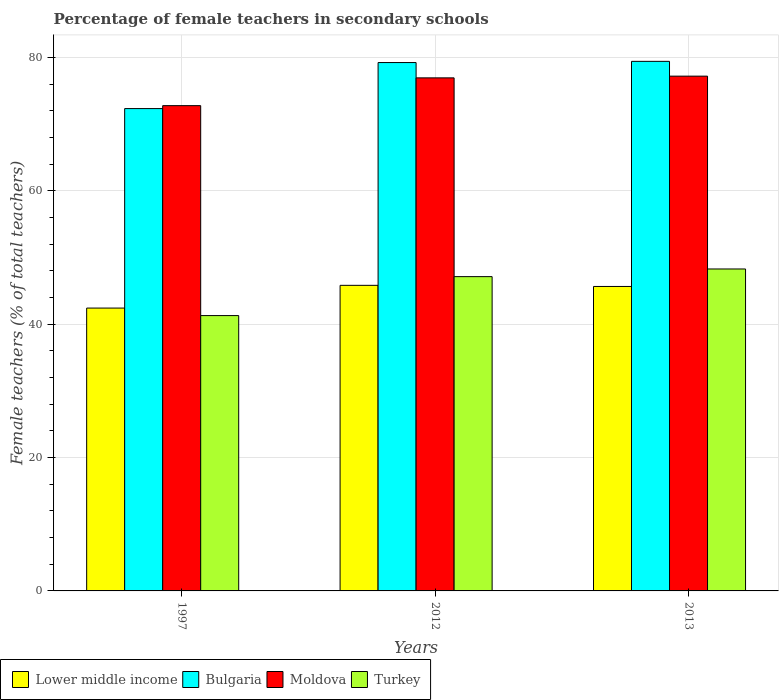How many groups of bars are there?
Offer a terse response. 3. Are the number of bars on each tick of the X-axis equal?
Your response must be concise. Yes. How many bars are there on the 1st tick from the left?
Ensure brevity in your answer.  4. In how many cases, is the number of bars for a given year not equal to the number of legend labels?
Make the answer very short. 0. What is the percentage of female teachers in Moldova in 1997?
Your response must be concise. 72.8. Across all years, what is the maximum percentage of female teachers in Lower middle income?
Ensure brevity in your answer.  45.84. Across all years, what is the minimum percentage of female teachers in Bulgaria?
Offer a very short reply. 72.36. In which year was the percentage of female teachers in Lower middle income maximum?
Provide a short and direct response. 2012. In which year was the percentage of female teachers in Bulgaria minimum?
Give a very brief answer. 1997. What is the total percentage of female teachers in Turkey in the graph?
Your answer should be very brief. 136.75. What is the difference between the percentage of female teachers in Moldova in 2012 and that in 2013?
Offer a very short reply. -0.26. What is the difference between the percentage of female teachers in Bulgaria in 1997 and the percentage of female teachers in Turkey in 2013?
Your response must be concise. 24.06. What is the average percentage of female teachers in Lower middle income per year?
Your answer should be compact. 44.65. In the year 2012, what is the difference between the percentage of female teachers in Turkey and percentage of female teachers in Bulgaria?
Keep it short and to the point. -32.12. In how many years, is the percentage of female teachers in Moldova greater than 40 %?
Make the answer very short. 3. What is the ratio of the percentage of female teachers in Lower middle income in 1997 to that in 2012?
Keep it short and to the point. 0.93. Is the percentage of female teachers in Turkey in 1997 less than that in 2013?
Ensure brevity in your answer.  Yes. Is the difference between the percentage of female teachers in Turkey in 1997 and 2013 greater than the difference between the percentage of female teachers in Bulgaria in 1997 and 2013?
Offer a terse response. Yes. What is the difference between the highest and the second highest percentage of female teachers in Bulgaria?
Your answer should be compact. 0.18. What is the difference between the highest and the lowest percentage of female teachers in Lower middle income?
Your answer should be very brief. 3.41. In how many years, is the percentage of female teachers in Bulgaria greater than the average percentage of female teachers in Bulgaria taken over all years?
Offer a very short reply. 2. Is it the case that in every year, the sum of the percentage of female teachers in Lower middle income and percentage of female teachers in Bulgaria is greater than the sum of percentage of female teachers in Moldova and percentage of female teachers in Turkey?
Make the answer very short. No. What does the 3rd bar from the right in 1997 represents?
Ensure brevity in your answer.  Bulgaria. How many bars are there?
Offer a very short reply. 12. How many years are there in the graph?
Keep it short and to the point. 3. Are the values on the major ticks of Y-axis written in scientific E-notation?
Give a very brief answer. No. Does the graph contain grids?
Your answer should be compact. Yes. How are the legend labels stacked?
Offer a terse response. Horizontal. What is the title of the graph?
Your response must be concise. Percentage of female teachers in secondary schools. What is the label or title of the Y-axis?
Your answer should be very brief. Female teachers (% of total teachers). What is the Female teachers (% of total teachers) in Lower middle income in 1997?
Provide a short and direct response. 42.43. What is the Female teachers (% of total teachers) in Bulgaria in 1997?
Give a very brief answer. 72.36. What is the Female teachers (% of total teachers) of Moldova in 1997?
Offer a very short reply. 72.8. What is the Female teachers (% of total teachers) in Turkey in 1997?
Offer a very short reply. 41.31. What is the Female teachers (% of total teachers) in Lower middle income in 2012?
Provide a short and direct response. 45.84. What is the Female teachers (% of total teachers) of Bulgaria in 2012?
Provide a short and direct response. 79.27. What is the Female teachers (% of total teachers) in Moldova in 2012?
Give a very brief answer. 76.97. What is the Female teachers (% of total teachers) of Turkey in 2012?
Offer a very short reply. 47.15. What is the Female teachers (% of total teachers) of Lower middle income in 2013?
Give a very brief answer. 45.68. What is the Female teachers (% of total teachers) of Bulgaria in 2013?
Offer a terse response. 79.45. What is the Female teachers (% of total teachers) of Moldova in 2013?
Your answer should be very brief. 77.23. What is the Female teachers (% of total teachers) in Turkey in 2013?
Provide a short and direct response. 48.3. Across all years, what is the maximum Female teachers (% of total teachers) in Lower middle income?
Keep it short and to the point. 45.84. Across all years, what is the maximum Female teachers (% of total teachers) in Bulgaria?
Provide a short and direct response. 79.45. Across all years, what is the maximum Female teachers (% of total teachers) of Moldova?
Your answer should be very brief. 77.23. Across all years, what is the maximum Female teachers (% of total teachers) of Turkey?
Provide a short and direct response. 48.3. Across all years, what is the minimum Female teachers (% of total teachers) in Lower middle income?
Ensure brevity in your answer.  42.43. Across all years, what is the minimum Female teachers (% of total teachers) in Bulgaria?
Offer a terse response. 72.36. Across all years, what is the minimum Female teachers (% of total teachers) in Moldova?
Provide a short and direct response. 72.8. Across all years, what is the minimum Female teachers (% of total teachers) of Turkey?
Offer a very short reply. 41.31. What is the total Female teachers (% of total teachers) in Lower middle income in the graph?
Your answer should be very brief. 133.95. What is the total Female teachers (% of total teachers) in Bulgaria in the graph?
Provide a short and direct response. 231.07. What is the total Female teachers (% of total teachers) of Moldova in the graph?
Offer a very short reply. 227. What is the total Female teachers (% of total teachers) in Turkey in the graph?
Your answer should be compact. 136.75. What is the difference between the Female teachers (% of total teachers) in Lower middle income in 1997 and that in 2012?
Offer a very short reply. -3.41. What is the difference between the Female teachers (% of total teachers) in Bulgaria in 1997 and that in 2012?
Your response must be concise. -6.91. What is the difference between the Female teachers (% of total teachers) of Moldova in 1997 and that in 2012?
Your response must be concise. -4.17. What is the difference between the Female teachers (% of total teachers) of Turkey in 1997 and that in 2012?
Give a very brief answer. -5.85. What is the difference between the Female teachers (% of total teachers) in Lower middle income in 1997 and that in 2013?
Give a very brief answer. -3.24. What is the difference between the Female teachers (% of total teachers) of Bulgaria in 1997 and that in 2013?
Ensure brevity in your answer.  -7.09. What is the difference between the Female teachers (% of total teachers) in Moldova in 1997 and that in 2013?
Ensure brevity in your answer.  -4.43. What is the difference between the Female teachers (% of total teachers) of Turkey in 1997 and that in 2013?
Your answer should be very brief. -6.99. What is the difference between the Female teachers (% of total teachers) of Lower middle income in 2012 and that in 2013?
Your answer should be compact. 0.17. What is the difference between the Female teachers (% of total teachers) in Bulgaria in 2012 and that in 2013?
Keep it short and to the point. -0.18. What is the difference between the Female teachers (% of total teachers) of Moldova in 2012 and that in 2013?
Provide a short and direct response. -0.26. What is the difference between the Female teachers (% of total teachers) of Turkey in 2012 and that in 2013?
Keep it short and to the point. -1.15. What is the difference between the Female teachers (% of total teachers) of Lower middle income in 1997 and the Female teachers (% of total teachers) of Bulgaria in 2012?
Your answer should be compact. -36.83. What is the difference between the Female teachers (% of total teachers) of Lower middle income in 1997 and the Female teachers (% of total teachers) of Moldova in 2012?
Offer a very short reply. -34.54. What is the difference between the Female teachers (% of total teachers) of Lower middle income in 1997 and the Female teachers (% of total teachers) of Turkey in 2012?
Provide a short and direct response. -4.72. What is the difference between the Female teachers (% of total teachers) of Bulgaria in 1997 and the Female teachers (% of total teachers) of Moldova in 2012?
Give a very brief answer. -4.61. What is the difference between the Female teachers (% of total teachers) in Bulgaria in 1997 and the Female teachers (% of total teachers) in Turkey in 2012?
Ensure brevity in your answer.  25.21. What is the difference between the Female teachers (% of total teachers) of Moldova in 1997 and the Female teachers (% of total teachers) of Turkey in 2012?
Provide a succinct answer. 25.65. What is the difference between the Female teachers (% of total teachers) in Lower middle income in 1997 and the Female teachers (% of total teachers) in Bulgaria in 2013?
Ensure brevity in your answer.  -37.01. What is the difference between the Female teachers (% of total teachers) of Lower middle income in 1997 and the Female teachers (% of total teachers) of Moldova in 2013?
Make the answer very short. -34.79. What is the difference between the Female teachers (% of total teachers) in Lower middle income in 1997 and the Female teachers (% of total teachers) in Turkey in 2013?
Keep it short and to the point. -5.86. What is the difference between the Female teachers (% of total teachers) of Bulgaria in 1997 and the Female teachers (% of total teachers) of Moldova in 2013?
Keep it short and to the point. -4.87. What is the difference between the Female teachers (% of total teachers) in Bulgaria in 1997 and the Female teachers (% of total teachers) in Turkey in 2013?
Keep it short and to the point. 24.06. What is the difference between the Female teachers (% of total teachers) in Moldova in 1997 and the Female teachers (% of total teachers) in Turkey in 2013?
Make the answer very short. 24.5. What is the difference between the Female teachers (% of total teachers) in Lower middle income in 2012 and the Female teachers (% of total teachers) in Bulgaria in 2013?
Your response must be concise. -33.6. What is the difference between the Female teachers (% of total teachers) of Lower middle income in 2012 and the Female teachers (% of total teachers) of Moldova in 2013?
Keep it short and to the point. -31.38. What is the difference between the Female teachers (% of total teachers) of Lower middle income in 2012 and the Female teachers (% of total teachers) of Turkey in 2013?
Your response must be concise. -2.45. What is the difference between the Female teachers (% of total teachers) in Bulgaria in 2012 and the Female teachers (% of total teachers) in Moldova in 2013?
Your answer should be very brief. 2.04. What is the difference between the Female teachers (% of total teachers) of Bulgaria in 2012 and the Female teachers (% of total teachers) of Turkey in 2013?
Ensure brevity in your answer.  30.97. What is the difference between the Female teachers (% of total teachers) in Moldova in 2012 and the Female teachers (% of total teachers) in Turkey in 2013?
Give a very brief answer. 28.67. What is the average Female teachers (% of total teachers) in Lower middle income per year?
Your answer should be compact. 44.65. What is the average Female teachers (% of total teachers) in Bulgaria per year?
Provide a short and direct response. 77.02. What is the average Female teachers (% of total teachers) of Moldova per year?
Make the answer very short. 75.67. What is the average Female teachers (% of total teachers) of Turkey per year?
Give a very brief answer. 45.58. In the year 1997, what is the difference between the Female teachers (% of total teachers) in Lower middle income and Female teachers (% of total teachers) in Bulgaria?
Offer a very short reply. -29.93. In the year 1997, what is the difference between the Female teachers (% of total teachers) in Lower middle income and Female teachers (% of total teachers) in Moldova?
Ensure brevity in your answer.  -30.37. In the year 1997, what is the difference between the Female teachers (% of total teachers) in Lower middle income and Female teachers (% of total teachers) in Turkey?
Your response must be concise. 1.13. In the year 1997, what is the difference between the Female teachers (% of total teachers) in Bulgaria and Female teachers (% of total teachers) in Moldova?
Make the answer very short. -0.44. In the year 1997, what is the difference between the Female teachers (% of total teachers) of Bulgaria and Female teachers (% of total teachers) of Turkey?
Your response must be concise. 31.05. In the year 1997, what is the difference between the Female teachers (% of total teachers) in Moldova and Female teachers (% of total teachers) in Turkey?
Your response must be concise. 31.5. In the year 2012, what is the difference between the Female teachers (% of total teachers) of Lower middle income and Female teachers (% of total teachers) of Bulgaria?
Offer a very short reply. -33.42. In the year 2012, what is the difference between the Female teachers (% of total teachers) in Lower middle income and Female teachers (% of total teachers) in Moldova?
Ensure brevity in your answer.  -31.12. In the year 2012, what is the difference between the Female teachers (% of total teachers) of Lower middle income and Female teachers (% of total teachers) of Turkey?
Offer a terse response. -1.31. In the year 2012, what is the difference between the Female teachers (% of total teachers) in Bulgaria and Female teachers (% of total teachers) in Moldova?
Offer a very short reply. 2.3. In the year 2012, what is the difference between the Female teachers (% of total teachers) of Bulgaria and Female teachers (% of total teachers) of Turkey?
Provide a short and direct response. 32.12. In the year 2012, what is the difference between the Female teachers (% of total teachers) in Moldova and Female teachers (% of total teachers) in Turkey?
Offer a terse response. 29.82. In the year 2013, what is the difference between the Female teachers (% of total teachers) of Lower middle income and Female teachers (% of total teachers) of Bulgaria?
Your answer should be compact. -33.77. In the year 2013, what is the difference between the Female teachers (% of total teachers) in Lower middle income and Female teachers (% of total teachers) in Moldova?
Provide a succinct answer. -31.55. In the year 2013, what is the difference between the Female teachers (% of total teachers) of Lower middle income and Female teachers (% of total teachers) of Turkey?
Offer a very short reply. -2.62. In the year 2013, what is the difference between the Female teachers (% of total teachers) of Bulgaria and Female teachers (% of total teachers) of Moldova?
Your answer should be very brief. 2.22. In the year 2013, what is the difference between the Female teachers (% of total teachers) in Bulgaria and Female teachers (% of total teachers) in Turkey?
Give a very brief answer. 31.15. In the year 2013, what is the difference between the Female teachers (% of total teachers) in Moldova and Female teachers (% of total teachers) in Turkey?
Offer a terse response. 28.93. What is the ratio of the Female teachers (% of total teachers) in Lower middle income in 1997 to that in 2012?
Provide a succinct answer. 0.93. What is the ratio of the Female teachers (% of total teachers) in Bulgaria in 1997 to that in 2012?
Your answer should be compact. 0.91. What is the ratio of the Female teachers (% of total teachers) in Moldova in 1997 to that in 2012?
Ensure brevity in your answer.  0.95. What is the ratio of the Female teachers (% of total teachers) in Turkey in 1997 to that in 2012?
Keep it short and to the point. 0.88. What is the ratio of the Female teachers (% of total teachers) in Lower middle income in 1997 to that in 2013?
Provide a short and direct response. 0.93. What is the ratio of the Female teachers (% of total teachers) of Bulgaria in 1997 to that in 2013?
Provide a short and direct response. 0.91. What is the ratio of the Female teachers (% of total teachers) of Moldova in 1997 to that in 2013?
Offer a terse response. 0.94. What is the ratio of the Female teachers (% of total teachers) of Turkey in 1997 to that in 2013?
Provide a succinct answer. 0.86. What is the ratio of the Female teachers (% of total teachers) of Lower middle income in 2012 to that in 2013?
Provide a succinct answer. 1. What is the ratio of the Female teachers (% of total teachers) in Turkey in 2012 to that in 2013?
Ensure brevity in your answer.  0.98. What is the difference between the highest and the second highest Female teachers (% of total teachers) in Lower middle income?
Offer a very short reply. 0.17. What is the difference between the highest and the second highest Female teachers (% of total teachers) of Bulgaria?
Your response must be concise. 0.18. What is the difference between the highest and the second highest Female teachers (% of total teachers) of Moldova?
Provide a succinct answer. 0.26. What is the difference between the highest and the second highest Female teachers (% of total teachers) of Turkey?
Provide a succinct answer. 1.15. What is the difference between the highest and the lowest Female teachers (% of total teachers) in Lower middle income?
Offer a terse response. 3.41. What is the difference between the highest and the lowest Female teachers (% of total teachers) of Bulgaria?
Make the answer very short. 7.09. What is the difference between the highest and the lowest Female teachers (% of total teachers) of Moldova?
Offer a very short reply. 4.43. What is the difference between the highest and the lowest Female teachers (% of total teachers) of Turkey?
Offer a very short reply. 6.99. 